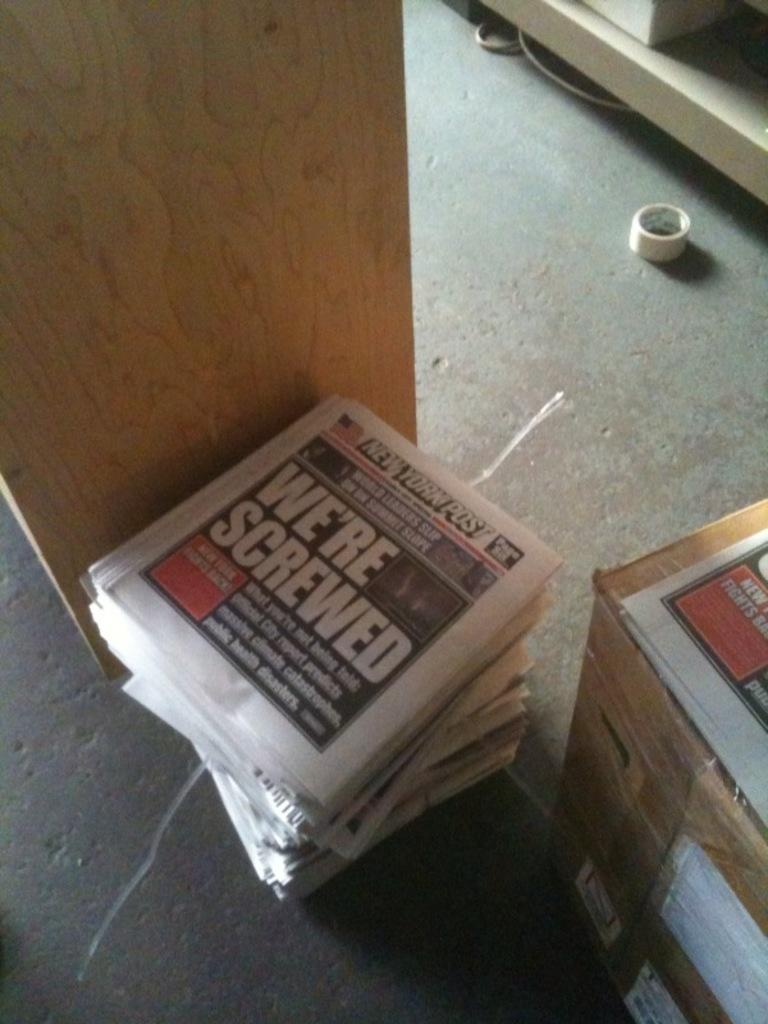Provide a one-sentence caption for the provided image. A stack of copies of the New York Post with a large headline reading 'we're screwed'. 